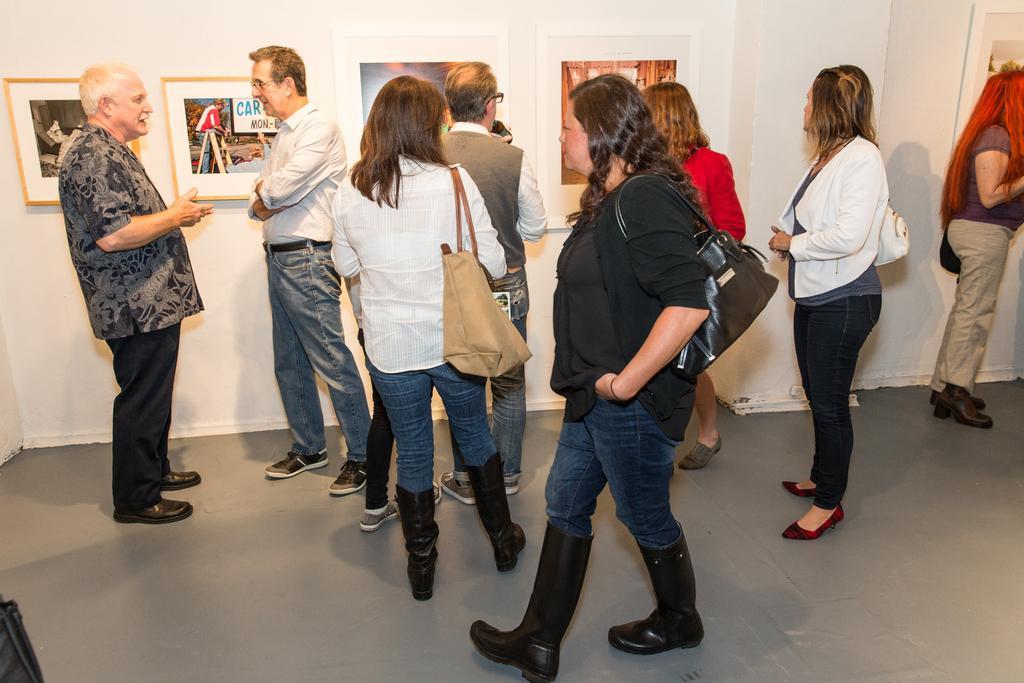Could you give a brief overview of what you see in this image? In this image we can see few persons are standing on the floor and among them few persons are carrying bags on the shoulder and a woman is walking on the floor and carrying a bag on her shoulder. In the background there are frames on the wall. 